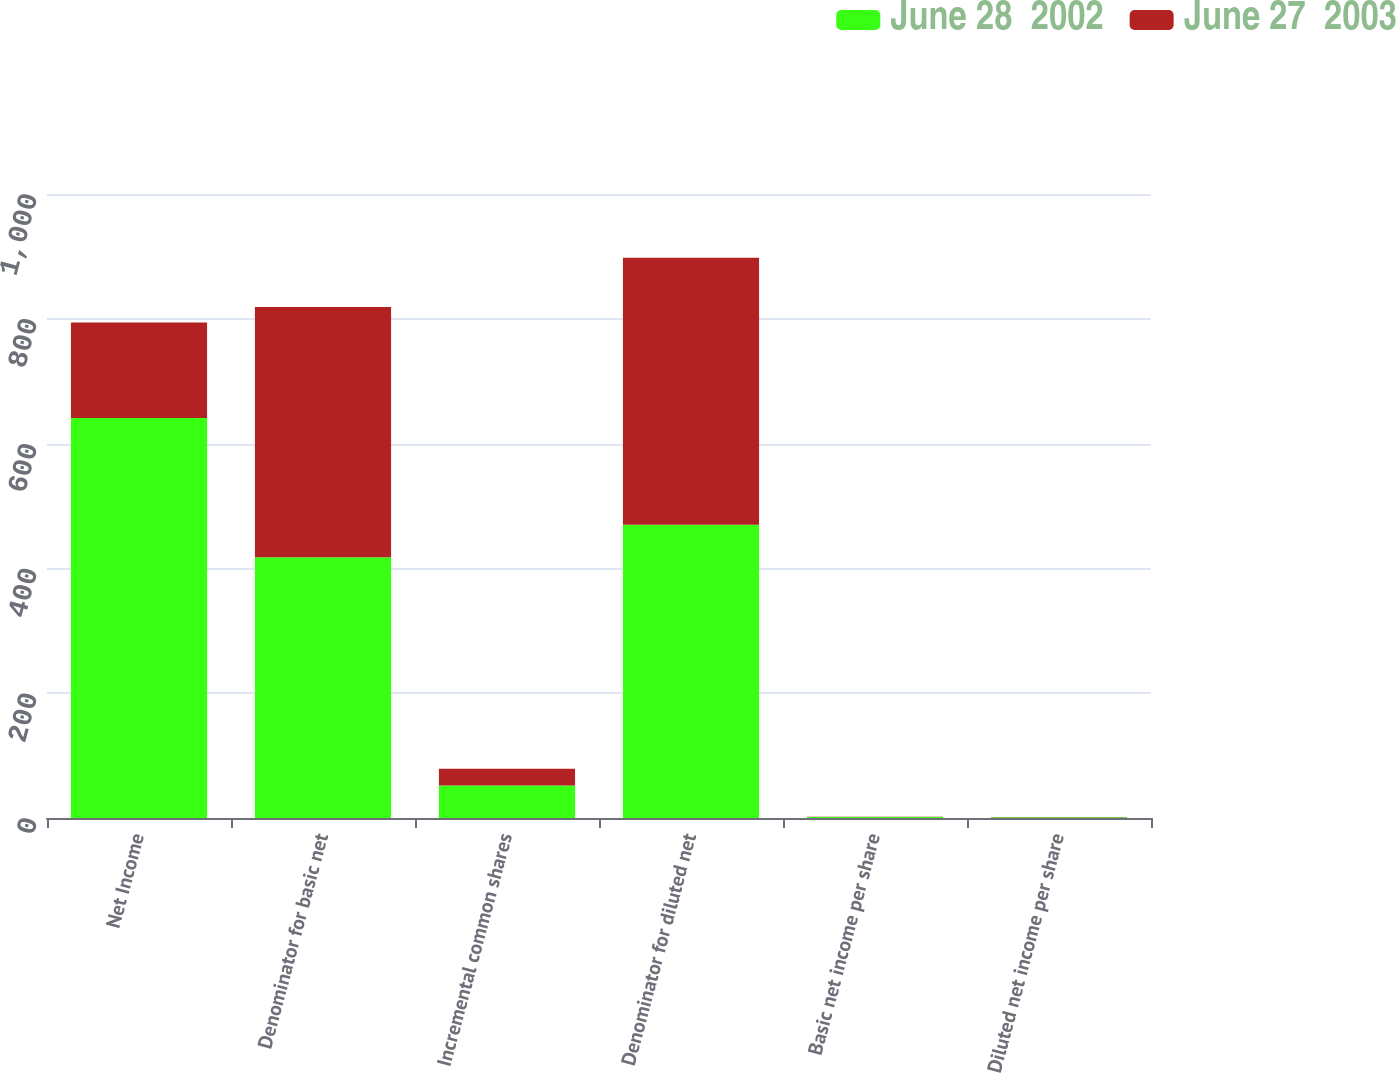<chart> <loc_0><loc_0><loc_500><loc_500><stacked_bar_chart><ecel><fcel>Net Income<fcel>Denominator for basic net<fcel>Incremental common shares<fcel>Denominator for diluted net<fcel>Basic net income per share<fcel>Diluted net income per share<nl><fcel>June 28  2002<fcel>641<fcel>418<fcel>52<fcel>470<fcel>1.53<fcel>1.36<nl><fcel>June 27  2003<fcel>153<fcel>401<fcel>27<fcel>428<fcel>0.38<fcel>0.36<nl></chart> 